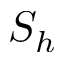Convert formula to latex. <formula><loc_0><loc_0><loc_500><loc_500>S _ { h }</formula> 